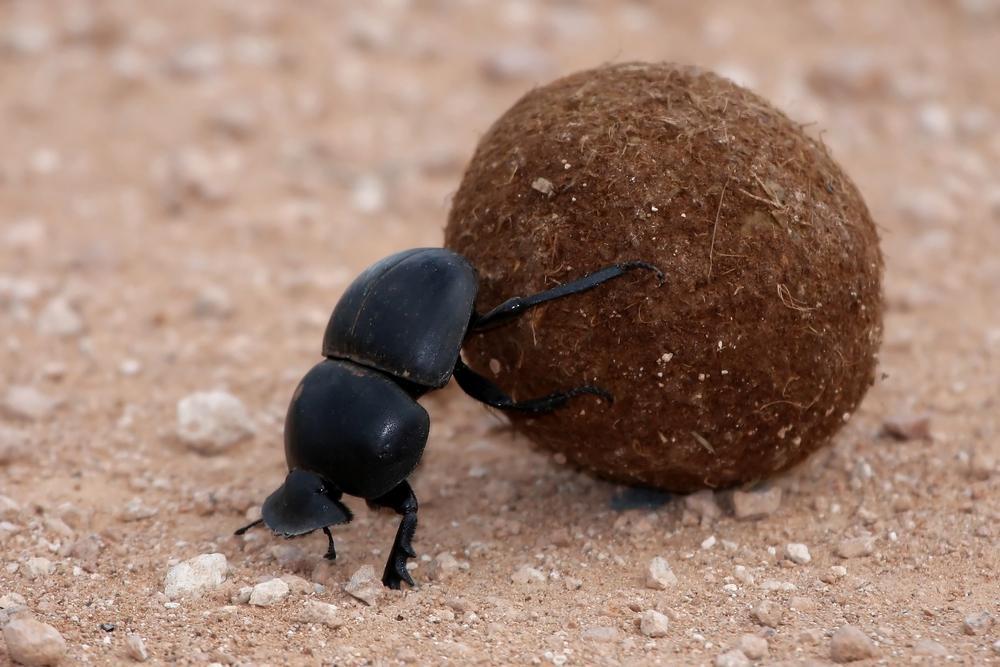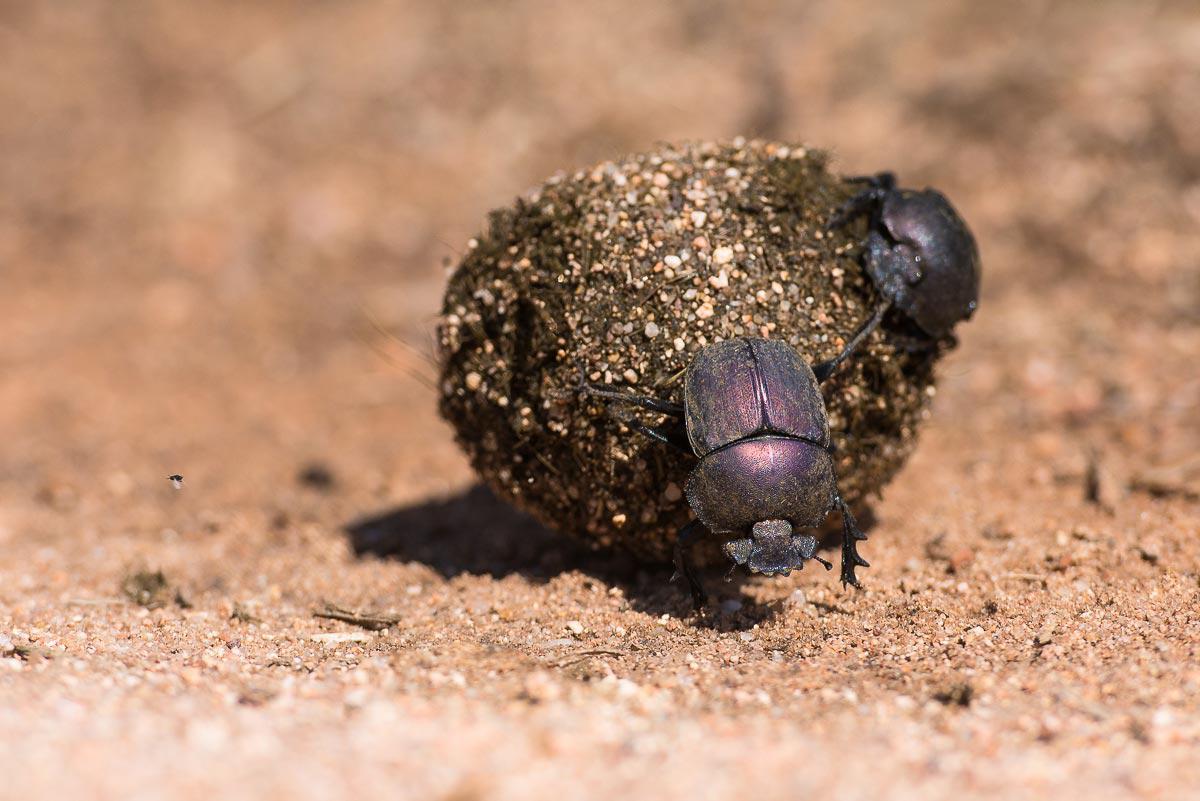The first image is the image on the left, the second image is the image on the right. For the images shown, is this caption "Left image shows one left-facing beetle with no dungball." true? Answer yes or no. No. The first image is the image on the left, the second image is the image on the right. Analyze the images presented: Is the assertion "There are two insects touching the ball in the image on the right" valid? Answer yes or no. Yes. 